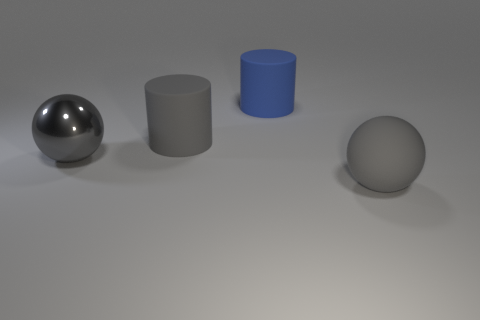Is there any other thing that has the same shape as the metallic thing?
Make the answer very short. Yes. What shape is the gray metal object?
Offer a very short reply. Sphere. There is a gray thing in front of the large gray metal sphere; is its shape the same as the blue matte object?
Offer a terse response. No. Are there more gray rubber cylinders that are to the right of the big gray cylinder than rubber things behind the metallic ball?
Provide a short and direct response. No. What number of other objects are the same size as the shiny thing?
Ensure brevity in your answer.  3. Do the blue object and the big gray shiny object in front of the blue matte object have the same shape?
Offer a terse response. No. How many shiny things are either big red balls or cylinders?
Offer a terse response. 0. Are there any tiny rubber blocks that have the same color as the large metallic thing?
Keep it short and to the point. No. Are any brown matte cubes visible?
Offer a terse response. No. Is the shape of the large blue rubber object the same as the gray metal object?
Ensure brevity in your answer.  No. 